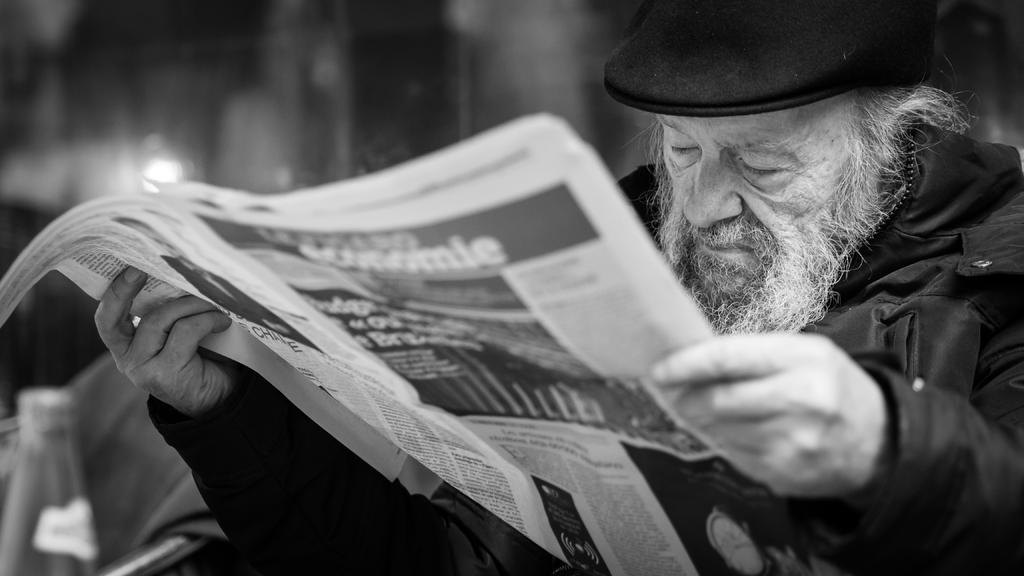Who is present in the image? There is a person in the image. What is the person holding in the image? The person is holding a paper. What color is the dress the person is wearing? The person is wearing a black color dress. What type of headwear is the person wearing? The person is wearing a black color cap on their head. Where is the person located in the image? The person is visible on the right side of the image. What type of wool is being used to increase the size of the ground in the image? There is no wool or ground present in the image, and therefore no such activity can be observed. 